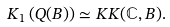<formula> <loc_0><loc_0><loc_500><loc_500>K _ { 1 } \left ( Q ( B ) \right ) \simeq K K ( \mathbb { C } , B ) .</formula> 